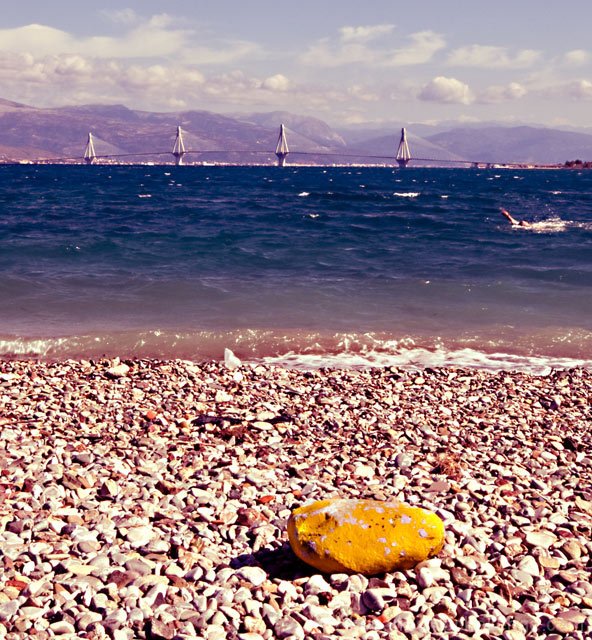Is the overall clarity of the image acceptable? The image is clear, with fine details visible in the pebbled beach and distinct shapes of sailboats on the horizon. The contrast in colors from the yellow rock in the foreground to the azure sea and mountains in the distance is captured well, offering a pleasing visual experience. 